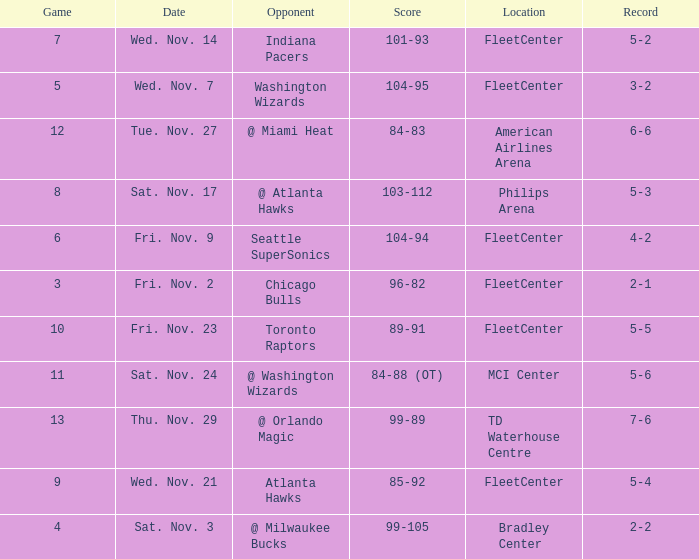What is the earliest game with a score of 99-89? 13.0. 